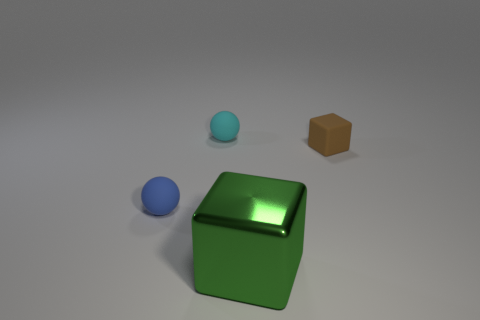Add 4 cyan matte spheres. How many objects exist? 8 Subtract all brown cubes. How many cubes are left? 1 Subtract 1 balls. How many balls are left? 1 Add 1 brown matte cubes. How many brown matte cubes are left? 2 Add 2 tiny blue rubber spheres. How many tiny blue rubber spheres exist? 3 Subtract 0 purple balls. How many objects are left? 4 Subtract all purple spheres. Subtract all gray cubes. How many spheres are left? 2 Subtract all purple rubber spheres. Subtract all metal blocks. How many objects are left? 3 